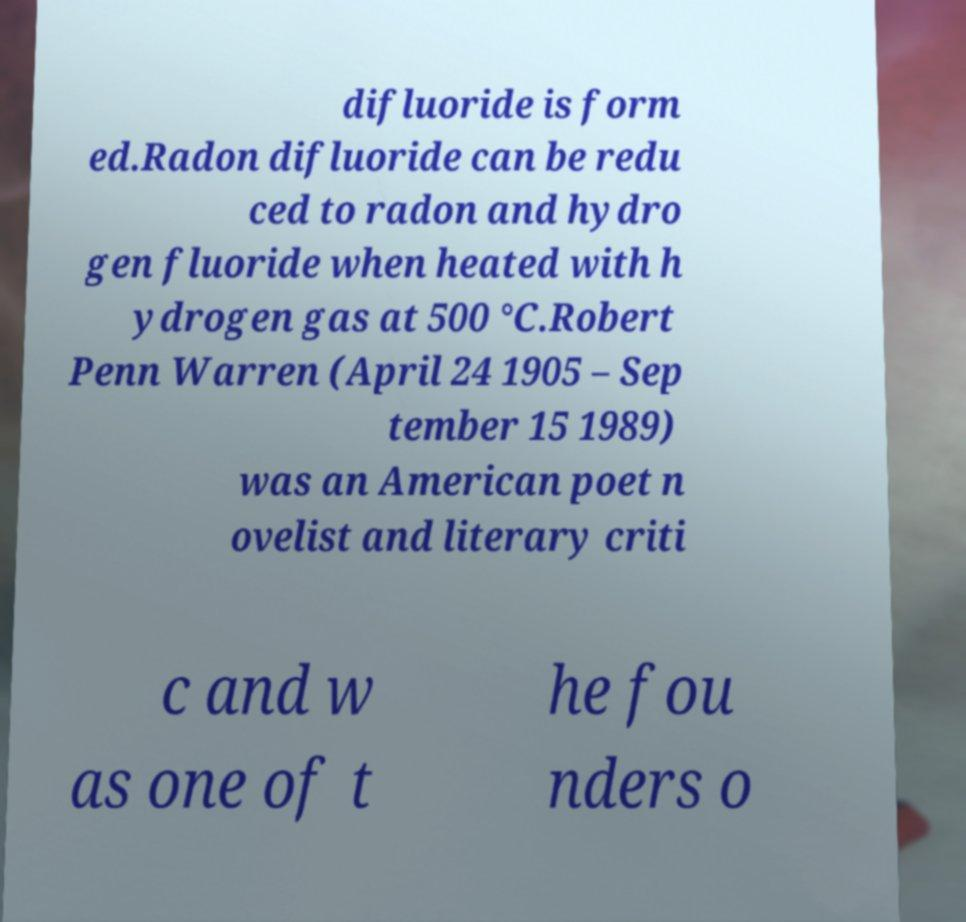For documentation purposes, I need the text within this image transcribed. Could you provide that? difluoride is form ed.Radon difluoride can be redu ced to radon and hydro gen fluoride when heated with h ydrogen gas at 500 °C.Robert Penn Warren (April 24 1905 – Sep tember 15 1989) was an American poet n ovelist and literary criti c and w as one of t he fou nders o 